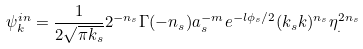Convert formula to latex. <formula><loc_0><loc_0><loc_500><loc_500>\psi _ { k } ^ { i n } = \frac { 1 } { 2 \sqrt { \pi k _ { s } } } 2 ^ { - n _ { s } } \Gamma ( - n _ { s } ) a _ { s } ^ { - m } e ^ { - l \phi _ { s } / 2 } ( k _ { s } k ) ^ { n _ { s } } \eta _ { . } ^ { 2 n _ { s } }</formula> 